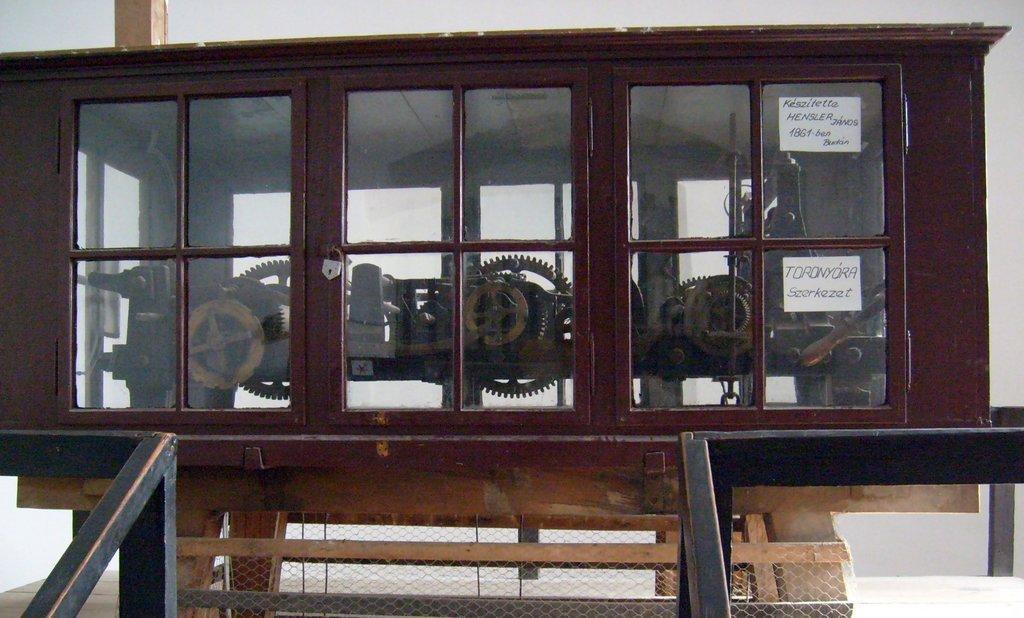In one or two sentences, can you explain what this image depicts? In this Image I can see the machine inside the box. The box is in maroon color and I can some White color papers attached to it. To the side there is a railing and net. In the back there is a white background. 